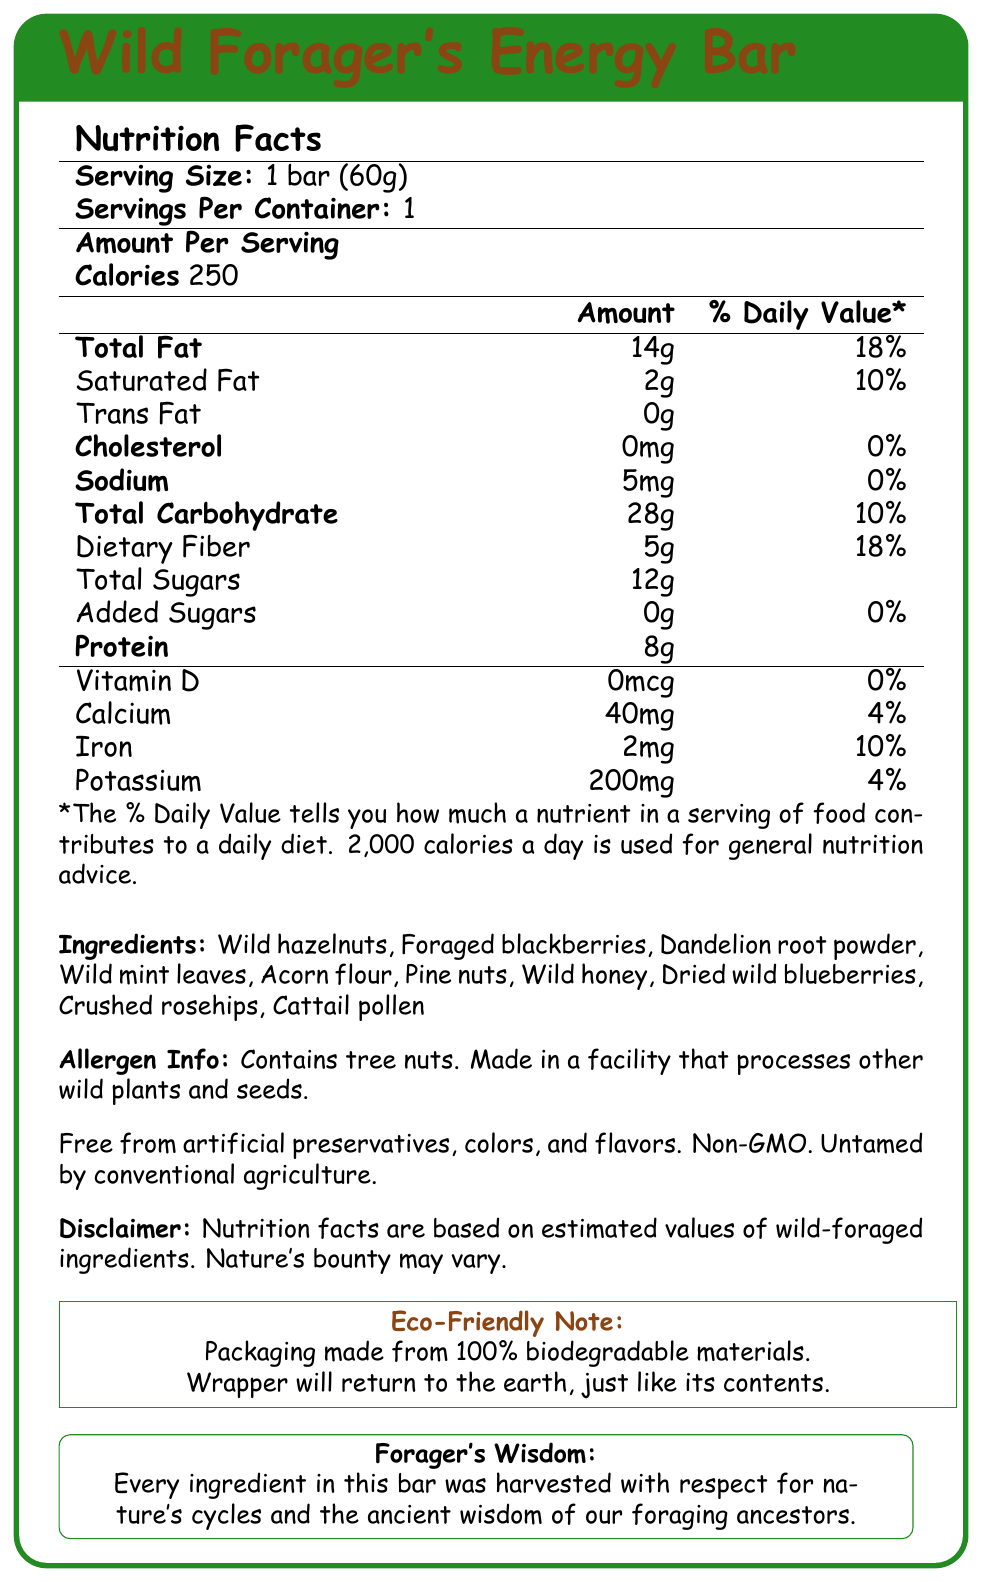What is the serving size of the Wild Forager's Energy Bar? The serving size is stated as "1 bar (60g)" in the nutrition facts section of the document.
Answer: 1 bar (60g) How many servings are contained in one package of the Wild Forager's Energy Bar? The document specifies that there is 1 serving per container.
Answer: 1 What is the total fat content of the energy bar? The total fat content is listed as 14g under the nutrition facts.
Answer: 14g Does the energy bar contain any trans fats? The nutrition facts section indicates that the trans fat content is 0g.
Answer: No What is the amount of dietary fiber in the bar? The dietary fiber amount is given as 5g in the nutrition facts section.
Answer: 5g What percentage of the daily value of calcium does the Wild Forager's Energy Bar provide? The daily value for calcium is listed as 4%.
Answer: 4% What are the primary ingredients in the energy bar? The ingredients are listed in the ingredients section.
Answer: Wild hazelnuts, Foraged blackberries, Dandelion root powder, Wild mint leaves, Acorn flour, Pine nuts, Wild honey, Dried wild blueberries, Crushed rosehips, Cattail pollen Which of the following nutrients does the Wild Forager's Energy Bar contain the most of per serving? A. Protein B. Dietary Fiber C. Total Sugars D. Sodium The bar contains 12g of Total Sugars, which is higher than the other listed nutrients per serving.
Answer: C. Total Sugars What is the calorie count of one serving of the Wild Forager's Energy Bar? A. 100 calories B. 200 calories C. 250 calories D. 300 calories The calorie count is specified as 250 in the nutrition facts section.
Answer: C. 250 calories Is the Wild Forager's Energy Bar made with artificial preservatives? The document states that the bar is free from artificial preservatives, colors, and flavors.
Answer: No Does the Wild Forager's Energy Bar contain any added sugars? The nutrition facts indicate that the amount of added sugars is 0g.
Answer: No Could someone with a tree nut allergy safely eat the Wild Forager's Energy Bar? The allergen information section specifies that the bar contains tree nuts.
Answer: No Summarize the main theme of the Wild Forager's Energy Bar document. The nutrition facts document gives detailed information about the Wild Forager's Energy Bar, highlighting its nutritional content, natural and GM-free ingredients, allergen information, and environmentally friendly packaging.
Answer: The document provides the nutritional facts, ingredient list, allergen information, and eco-friendly notes for a DIY energy bar made from foraged wild plants and nuts, emphasizing natural ingredients and sustainability. What wild ingredient contributes most to the total carbohydrate content of the bar? The document does not specify which individual ingredient contributes the most to the total carbohydrate content.
Answer: Not enough information 